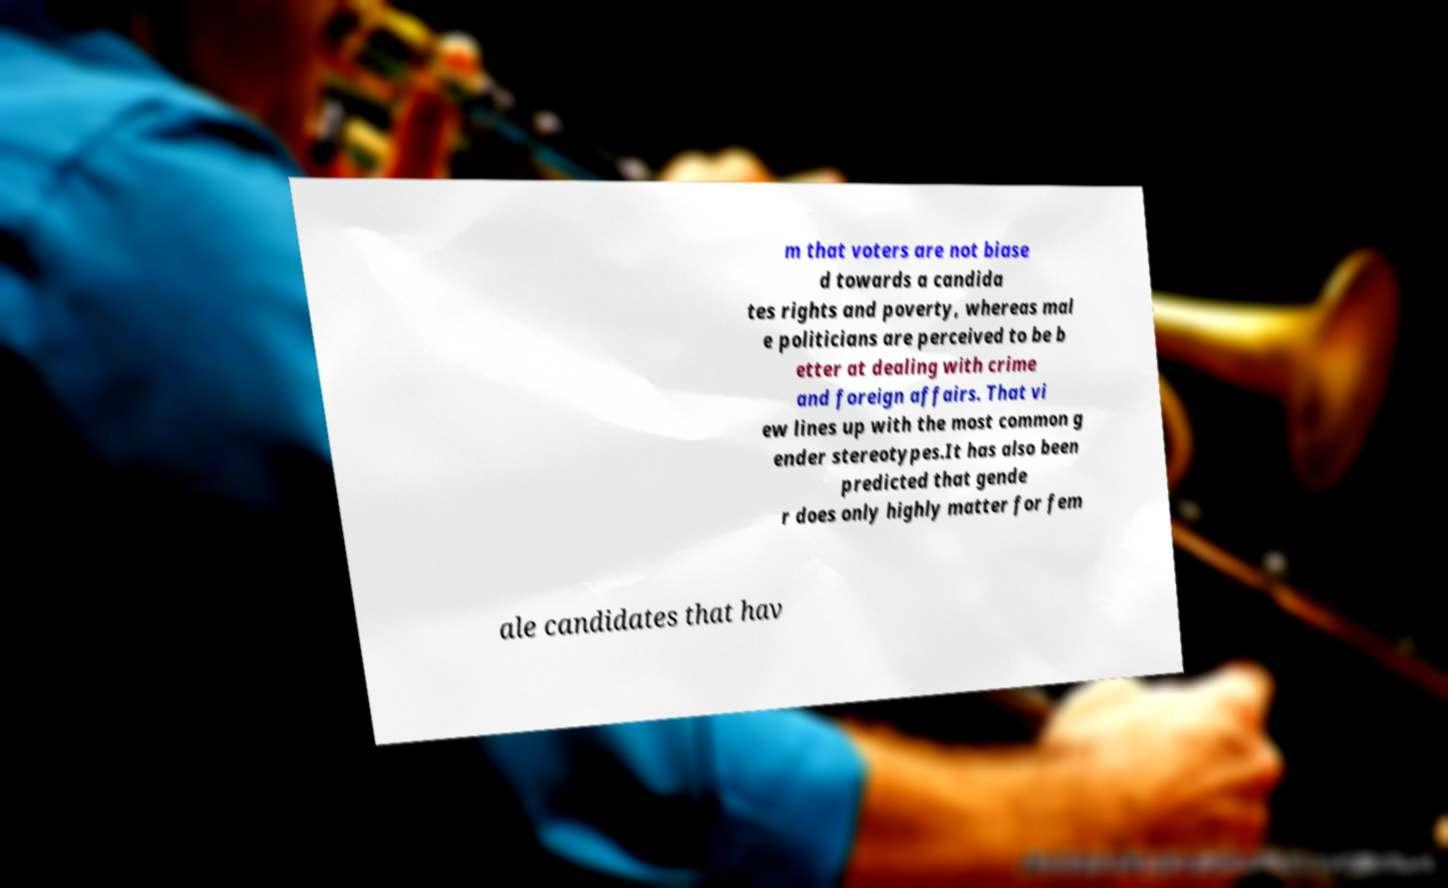Can you accurately transcribe the text from the provided image for me? m that voters are not biase d towards a candida tes rights and poverty, whereas mal e politicians are perceived to be b etter at dealing with crime and foreign affairs. That vi ew lines up with the most common g ender stereotypes.It has also been predicted that gende r does only highly matter for fem ale candidates that hav 